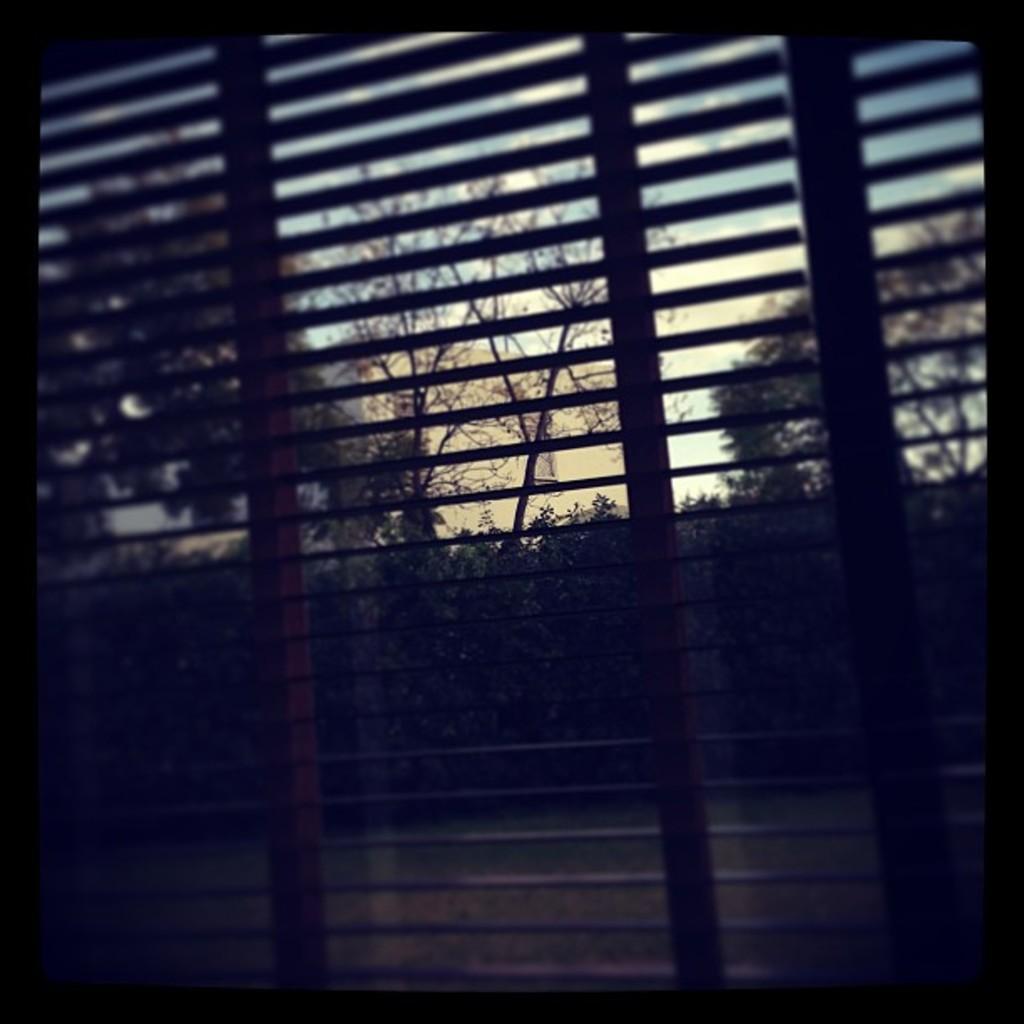In one or two sentences, can you explain what this image depicts? In this image I can see a window, trees, grass and the sky. This image is taken may be during a day and looks like a photo frame. 